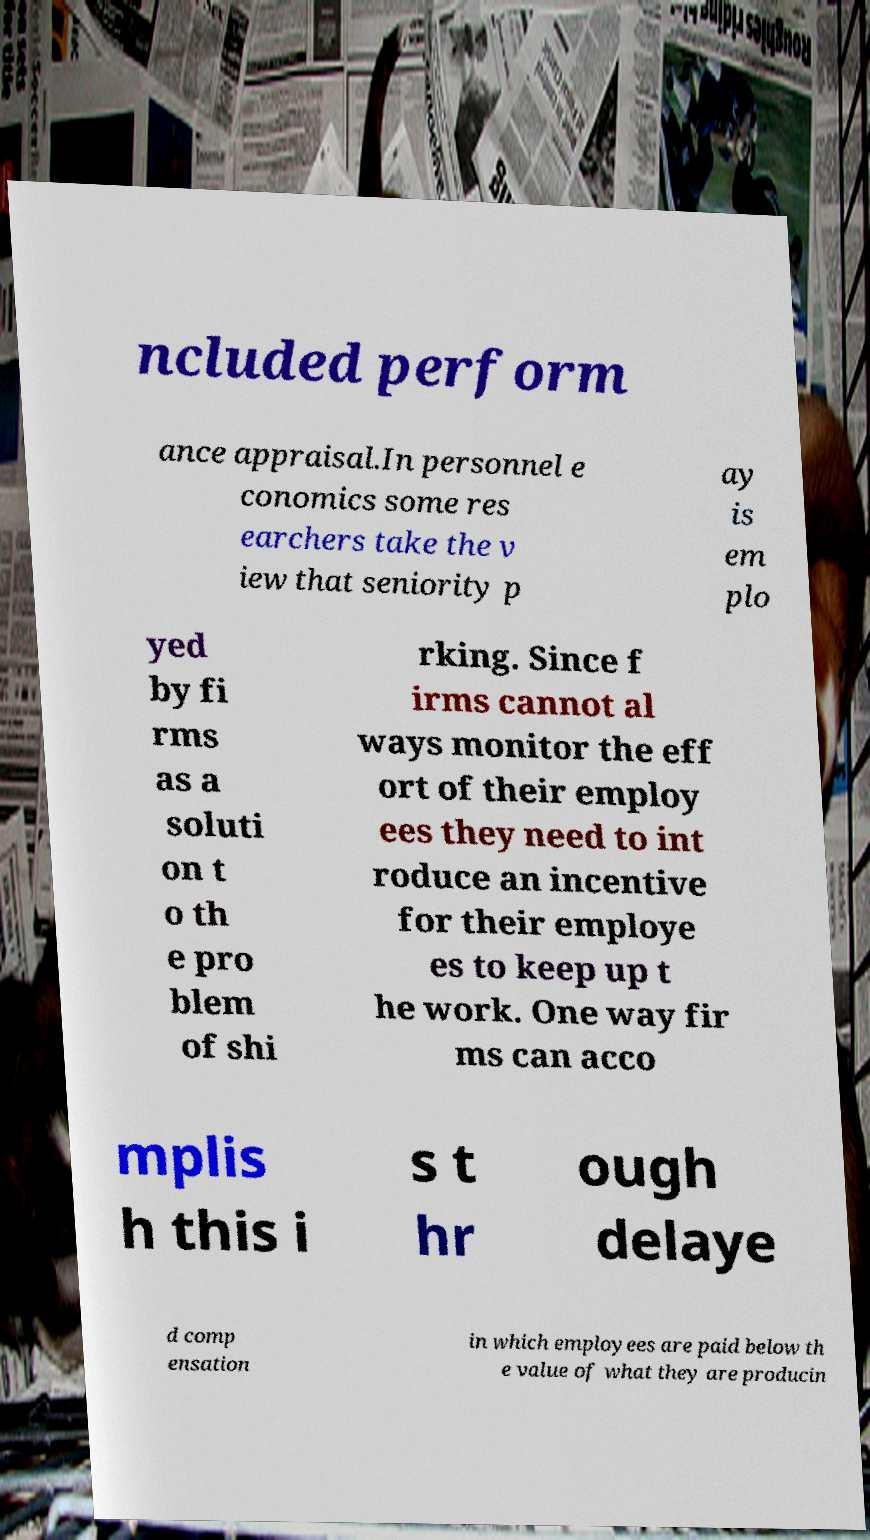Can you read and provide the text displayed in the image?This photo seems to have some interesting text. Can you extract and type it out for me? ncluded perform ance appraisal.In personnel e conomics some res earchers take the v iew that seniority p ay is em plo yed by fi rms as a soluti on t o th e pro blem of shi rking. Since f irms cannot al ways monitor the eff ort of their employ ees they need to int roduce an incentive for their employe es to keep up t he work. One way fir ms can acco mplis h this i s t hr ough delaye d comp ensation in which employees are paid below th e value of what they are producin 